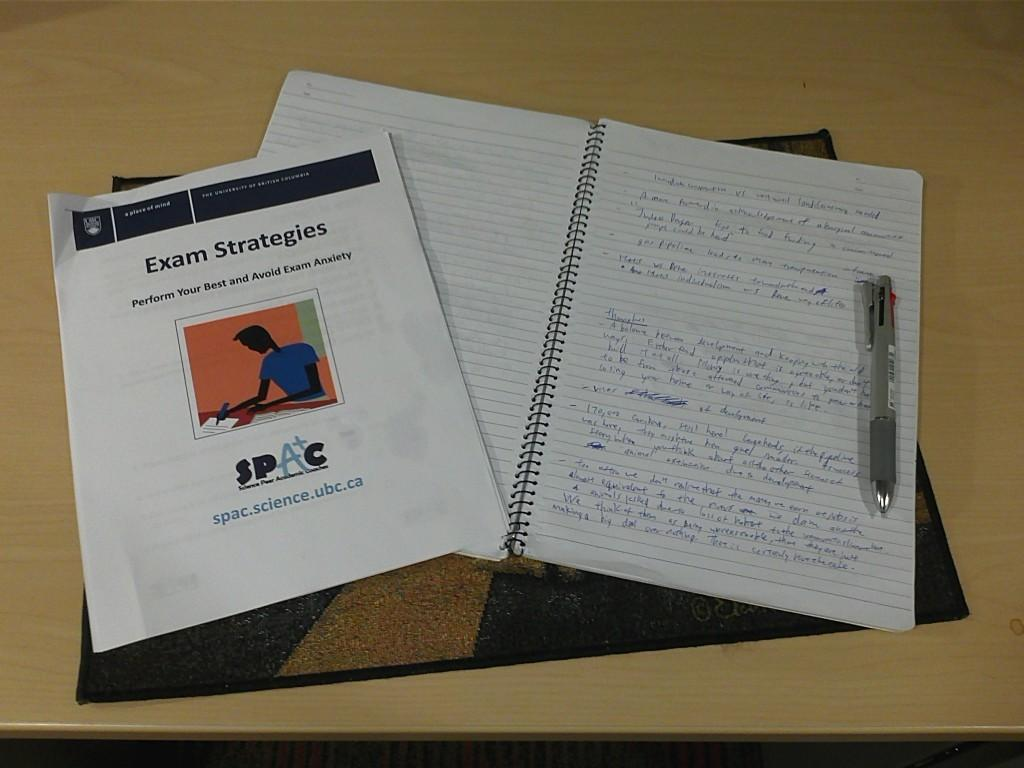<image>
Offer a succinct explanation of the picture presented. The exam strategies printout helps one to learn to avoid exam anxiety. 